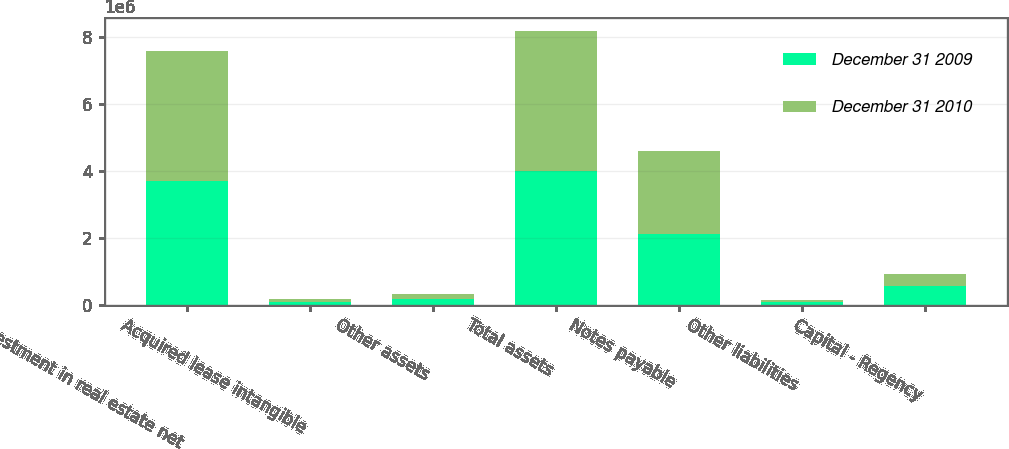Convert chart to OTSL. <chart><loc_0><loc_0><loc_500><loc_500><stacked_bar_chart><ecel><fcel>Investment in real estate net<fcel>Acquired lease intangible<fcel>Other assets<fcel>Total assets<fcel>Notes payable<fcel>Other liabilities<fcel>Capital - Regency<nl><fcel>December 31 2009<fcel>3.68656e+06<fcel>75551<fcel>176394<fcel>3.98312e+06<fcel>2.1177e+06<fcel>69230<fcel>557374<nl><fcel>December 31 2010<fcel>3.90028e+06<fcel>87009<fcel>137753<fcel>4.18518e+06<fcel>2.47793e+06<fcel>80011<fcel>375076<nl></chart> 